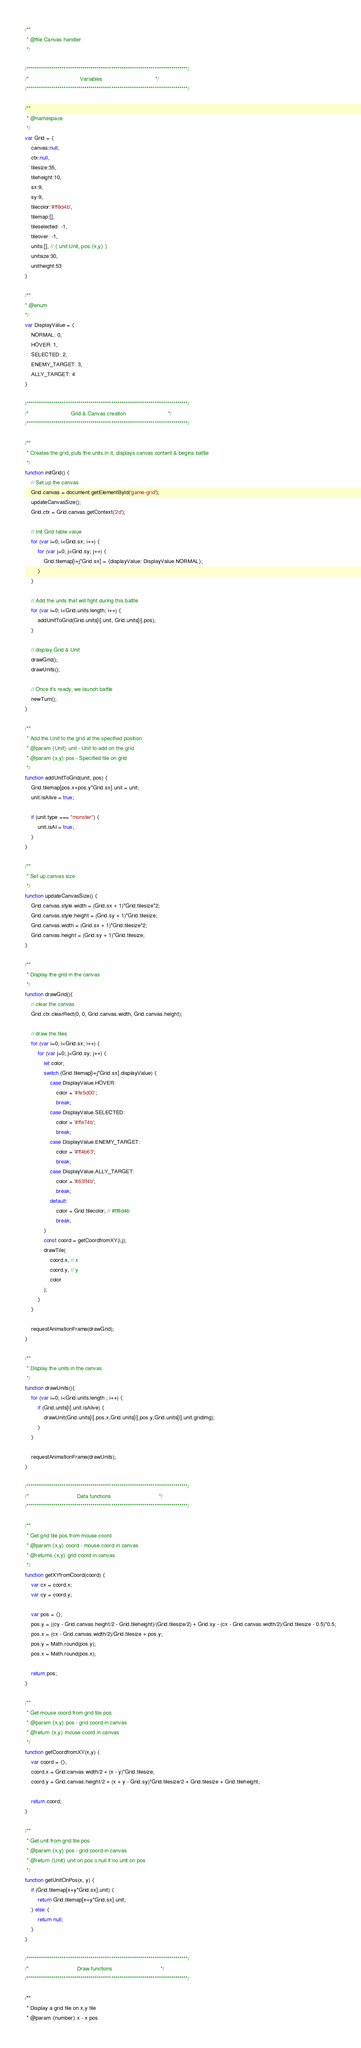<code> <loc_0><loc_0><loc_500><loc_500><_JavaScript_>/**
 * @file Canvas handler
 */

/******************************************************************************/
/*                                 Variables                                  */
/******************************************************************************/

/**
 * @namespace
 */
var Grid = {
    canvas:null,
    ctx:null,
    tilesize:35,
    tileheight:10,
    sx:9,
    sy:9,
    tilecolor:'#ff8d4b',
    tilemap:[],
    tileselected: -1,
    tileover: -1,
    units:[], // { unit:Unit, pos:{x,y} }
    unitsize:30,
    unitheight:53
}

/**
* @enum
*/
var DisplayValue = {
    NORMAL: 0,
    HOVER: 1,
    SELECTED: 2,
    ENEMY_TARGET: 3,
    ALLY_TARGET: 4
}

/******************************************************************************/
/*                           Grid & Canvas creation                           */
/******************************************************************************/

/**
 * Creates the grid, puts the units in it, displays canvas content & begins battle
 */
function initGrid() {
    // Set up the canvas
    Grid.canvas = document.getElementById('game-grid');
    updateCanvasSize();
    Grid.ctx = Grid.canvas.getContext('2d');

    // Init Grid table value
    for (var i=0; i<Grid.sx; i++) {
        for (var j=0; j<Grid.sy; j++) {
            Grid.tilemap[i+j*Grid.sx] = {displayValue: DisplayValue.NORMAL};
        }
    }

    // Add the units that will fight during this battle
    for (var i=0; i<Grid.units.length; i++) {
        addUnitToGrid(Grid.units[i].unit, Grid.units[i].pos);
    }

    // display Grid & Unit
    drawGrid();
    drawUnits();

    // Once it's ready, we launch battle
    newTurn();
}

/**
 * Add the Unit to the grid at the specified position
 * @param {Unit} unit - Unit to add on the grid
 * @param {x,y} pos - Specified tile on grid
 */
function addUnitToGrid(unit, pos) {
    Grid.tilemap[pos.x+pos.y*Grid.sx].unit = unit;
    unit.isAlive = true;

    if (unit.type === "monster") {
        unit.isAI = true;
    }
}

/**
 * Set up canvas size
 */
function updateCanvasSize() {
    Grid.canvas.style.width = (Grid.sx + 1)*Grid.tilesize*2;
    Grid.canvas.style.height = (Grid.sy + 1)*Grid.tilesize;
    Grid.canvas.width = (Grid.sx + 1)*Grid.tilesize*2;
    Grid.canvas.height = (Grid.sy + 1)*Grid.tilesize;
}

/**
 * Display the grid in the canvas
 */
function drawGrid(){
    // clear the canvas
    Grid.ctx.clearRect(0, 0, Grid.canvas.width, Grid.canvas.height);

    // draw the tiles
    for (var i=0; i<Grid.sx; i++) {
        for (var j=0; j<Grid.sy; j++) {
            let color;
            switch (Grid.tilemap[i+j*Grid.sx].displayValue) {
                case DisplayValue.HOVER:
                    color = '#fe5d00';
                    break;
                case DisplayValue.SELECTED:
                    color = '#ffe74b';
                    break;
                case DisplayValue.ENEMY_TARGET:
                    color = '#ff4b63';
                    break;
                case DisplayValue.ALLY_TARGET:
                    color = '#63ff4b';
                    break;
                default:
                    color = Grid.tilecolor; // #ff8d4b
                    break;
            }
            const coord = getCoordfromXY(i,j);
            drawTile(
                coord.x, // x
                coord.y, // y
                color
            );
        }
    }

    requestAnimationFrame(drawGrid);
}

/**
 * Display the units in the canvas
 */
function drawUnits(){
    for (var i=0; i<Grid.units.length ; i++) {
        if (Grid.units[i].unit.isAlive) {
            drawUnit(Grid.units[i].pos.x,Grid.units[i].pos.y,Grid.units[i].unit.gridImg);
        }
    }

    requestAnimationFrame(drawUnits);
}

/******************************************************************************/
/*                               Data functions                               */
/******************************************************************************/

/**
 * Get grid tile pos from mouse coord
 * @param {x,y} coord - mouse coord in canvas
 * @returns {x,y} grid coord in canvas
 */
function getXYfromCoord(coord) {
    var cx = coord.x;
    var cy = coord.y;

    var pos = {};
    pos.y = ((cy - Grid.canvas.height/2 - Grid.tileheight)/(Grid.tilesize/2) + Grid.sy - (cx - Grid.canvas.width/2)/Grid.tilesize - 0.5)*0.5;
    pos.x = (cx - Grid.canvas.width/2)/Grid.tilesize + pos.y;
    pos.y = Math.round(pos.y);
    pos.x = Math.round(pos.x);

    return pos;
}

/**
 * Get mouse coord from grid tile pos
 * @param {x,y} pos - grid coord in canvas
 * @return {x,y} mouse coord in canvas
 */
function getCoordfromXY(x,y) {
    var coord = {};
    coord.x = Grid.canvas.width/2 + (x - y)*Grid.tilesize;
    coord.y = Grid.canvas.height/2 + (x + y - Grid.sy)*Grid.tilesize/2 + Grid.tilesize + Grid.tileheight;

    return coord;
}

/**
 * Get unit from grid tile pos
 * @param {x,y} pos - grid coord in canvas
 * @return {Unit} unit on pos || null if no unit on pos
 */
function getUnitOnPos(x, y) {
    if (Grid.tilemap[x+y*Grid.sx].unit) {
        return Grid.tilemap[x+y*Grid.sx].unit;
    } else {
        return null;
    }
}

/******************************************************************************/
/*                               Draw functions                               */
/******************************************************************************/

/**
 * Display a grid tile on x,y tile
 * @param {number} x - x pos</code> 